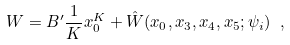<formula> <loc_0><loc_0><loc_500><loc_500>W = B ^ { \prime } \frac { 1 } { K } x ^ { K } _ { 0 } + \hat { W } ( x _ { 0 } , x _ { 3 } , x _ { 4 } , x _ { 5 } ; \psi _ { i } ) \ ,</formula> 